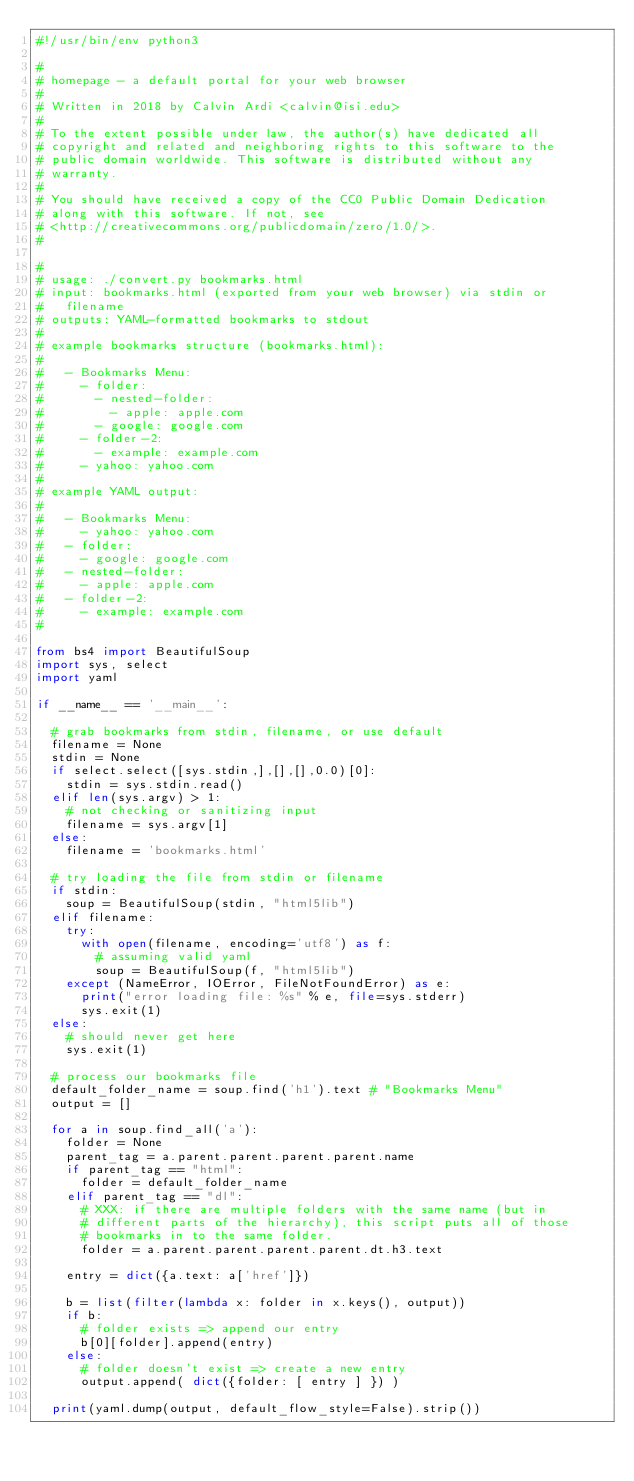Convert code to text. <code><loc_0><loc_0><loc_500><loc_500><_Python_>#!/usr/bin/env python3

#
# homepage - a default portal for your web browser
#
# Written in 2018 by Calvin Ardi <calvin@isi.edu>
#
# To the extent possible under law, the author(s) have dedicated all
# copyright and related and neighboring rights to this software to the
# public domain worldwide. This software is distributed without any
# warranty.
#
# You should have received a copy of the CC0 Public Domain Dedication
# along with this software. If not, see
# <http://creativecommons.org/publicdomain/zero/1.0/>.
#

#
# usage: ./convert.py bookmarks.html
# input: bookmarks.html (exported from your web browser) via stdin or
#   filename
# outputs: YAML-formatted bookmarks to stdout
# 
# example bookmarks structure (bookmarks.html):
# 
#   - Bookmarks Menu:
#     - folder:
#       - nested-folder:
#         - apple: apple.com
#       - google: google.com
#     - folder-2:
#       - example: example.com
#     - yahoo: yahoo.com
# 
# example YAML output:
# 
#   - Bookmarks Menu:
#     - yahoo: yahoo.com
#   - folder:
#     - google: google.com
#   - nested-folder:
#     - apple: apple.com
#   - folder-2:
#     - example: example.com
#

from bs4 import BeautifulSoup
import sys, select
import yaml

if __name__ == '__main__':

  # grab bookmarks from stdin, filename, or use default
  filename = None
  stdin = None
  if select.select([sys.stdin,],[],[],0.0)[0]:
    stdin = sys.stdin.read()
  elif len(sys.argv) > 1:
    # not checking or sanitizing input
    filename = sys.argv[1]
  else:
    filename = 'bookmarks.html'

  # try loading the file from stdin or filename
  if stdin:
    soup = BeautifulSoup(stdin, "html5lib")
  elif filename:
    try:
      with open(filename, encoding='utf8') as f:
        # assuming valid yaml
        soup = BeautifulSoup(f, "html5lib")
    except (NameError, IOError, FileNotFoundError) as e:
      print("error loading file: %s" % e, file=sys.stderr)
      sys.exit(1)
  else:
    # should never get here
    sys.exit(1)
 
  # process our bookmarks file 
  default_folder_name = soup.find('h1').text # "Bookmarks Menu"
  output = []

  for a in soup.find_all('a'):
    folder = None
    parent_tag = a.parent.parent.parent.parent.name
    if parent_tag == "html":
      folder = default_folder_name
    elif parent_tag == "dl":
      # XXX: if there are multiple folders with the same name (but in
      # different parts of the hierarchy), this script puts all of those
      # bookmarks in to the same folder.
      folder = a.parent.parent.parent.parent.dt.h3.text

    entry = dict({a.text: a['href']})

    b = list(filter(lambda x: folder in x.keys(), output))
    if b: 
      # folder exists => append our entry
      b[0][folder].append(entry)
    else:
      # folder doesn't exist => create a new entry
      output.append( dict({folder: [ entry ] }) )

  print(yaml.dump(output, default_flow_style=False).strip())
</code> 